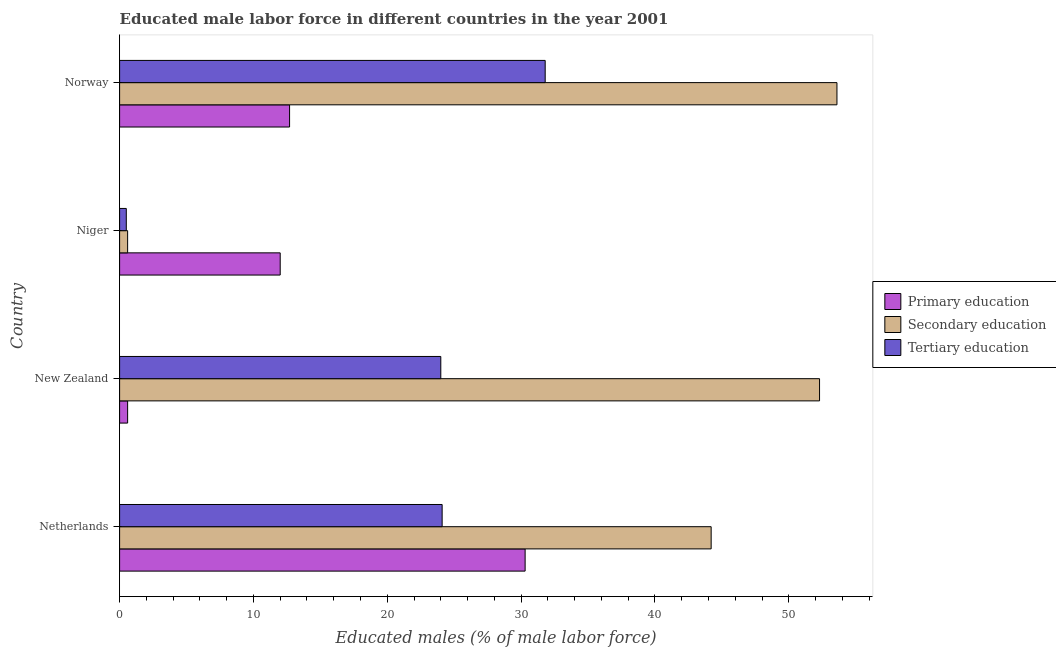How many bars are there on the 3rd tick from the top?
Ensure brevity in your answer.  3. How many bars are there on the 3rd tick from the bottom?
Provide a succinct answer. 3. What is the label of the 4th group of bars from the top?
Your answer should be very brief. Netherlands. What is the percentage of male labor force who received secondary education in Niger?
Give a very brief answer. 0.6. Across all countries, what is the maximum percentage of male labor force who received tertiary education?
Keep it short and to the point. 31.8. Across all countries, what is the minimum percentage of male labor force who received primary education?
Make the answer very short. 0.6. In which country was the percentage of male labor force who received primary education maximum?
Keep it short and to the point. Netherlands. In which country was the percentage of male labor force who received secondary education minimum?
Offer a terse response. Niger. What is the total percentage of male labor force who received primary education in the graph?
Offer a terse response. 55.6. What is the difference between the percentage of male labor force who received tertiary education in Netherlands and that in Niger?
Your answer should be very brief. 23.6. What is the difference between the percentage of male labor force who received primary education in Norway and the percentage of male labor force who received secondary education in Niger?
Your response must be concise. 12.1. What is the average percentage of male labor force who received secondary education per country?
Offer a very short reply. 37.67. What is the difference between the percentage of male labor force who received primary education and percentage of male labor force who received tertiary education in New Zealand?
Provide a succinct answer. -23.4. What is the ratio of the percentage of male labor force who received tertiary education in Netherlands to that in Niger?
Make the answer very short. 48.2. What is the difference between the highest and the second highest percentage of male labor force who received secondary education?
Provide a short and direct response. 1.3. What is the difference between the highest and the lowest percentage of male labor force who received primary education?
Your answer should be compact. 29.7. Is the sum of the percentage of male labor force who received secondary education in New Zealand and Norway greater than the maximum percentage of male labor force who received primary education across all countries?
Make the answer very short. Yes. What does the 1st bar from the top in Netherlands represents?
Provide a short and direct response. Tertiary education. What does the 2nd bar from the bottom in Norway represents?
Provide a short and direct response. Secondary education. Is it the case that in every country, the sum of the percentage of male labor force who received primary education and percentage of male labor force who received secondary education is greater than the percentage of male labor force who received tertiary education?
Provide a short and direct response. Yes. How many bars are there?
Keep it short and to the point. 12. Are all the bars in the graph horizontal?
Give a very brief answer. Yes. Are the values on the major ticks of X-axis written in scientific E-notation?
Offer a very short reply. No. Where does the legend appear in the graph?
Make the answer very short. Center right. How many legend labels are there?
Offer a terse response. 3. What is the title of the graph?
Your answer should be compact. Educated male labor force in different countries in the year 2001. Does "Consumption Tax" appear as one of the legend labels in the graph?
Your answer should be compact. No. What is the label or title of the X-axis?
Offer a terse response. Educated males (% of male labor force). What is the label or title of the Y-axis?
Offer a terse response. Country. What is the Educated males (% of male labor force) of Primary education in Netherlands?
Provide a short and direct response. 30.3. What is the Educated males (% of male labor force) in Secondary education in Netherlands?
Your answer should be very brief. 44.2. What is the Educated males (% of male labor force) of Tertiary education in Netherlands?
Offer a very short reply. 24.1. What is the Educated males (% of male labor force) of Primary education in New Zealand?
Offer a very short reply. 0.6. What is the Educated males (% of male labor force) of Secondary education in New Zealand?
Provide a succinct answer. 52.3. What is the Educated males (% of male labor force) in Tertiary education in New Zealand?
Provide a succinct answer. 24. What is the Educated males (% of male labor force) of Secondary education in Niger?
Your answer should be compact. 0.6. What is the Educated males (% of male labor force) of Tertiary education in Niger?
Provide a succinct answer. 0.5. What is the Educated males (% of male labor force) of Primary education in Norway?
Keep it short and to the point. 12.7. What is the Educated males (% of male labor force) in Secondary education in Norway?
Provide a succinct answer. 53.6. What is the Educated males (% of male labor force) of Tertiary education in Norway?
Provide a succinct answer. 31.8. Across all countries, what is the maximum Educated males (% of male labor force) in Primary education?
Give a very brief answer. 30.3. Across all countries, what is the maximum Educated males (% of male labor force) in Secondary education?
Your answer should be very brief. 53.6. Across all countries, what is the maximum Educated males (% of male labor force) in Tertiary education?
Provide a short and direct response. 31.8. Across all countries, what is the minimum Educated males (% of male labor force) of Primary education?
Your response must be concise. 0.6. Across all countries, what is the minimum Educated males (% of male labor force) of Secondary education?
Keep it short and to the point. 0.6. Across all countries, what is the minimum Educated males (% of male labor force) of Tertiary education?
Offer a very short reply. 0.5. What is the total Educated males (% of male labor force) in Primary education in the graph?
Give a very brief answer. 55.6. What is the total Educated males (% of male labor force) of Secondary education in the graph?
Provide a short and direct response. 150.7. What is the total Educated males (% of male labor force) of Tertiary education in the graph?
Your answer should be compact. 80.4. What is the difference between the Educated males (% of male labor force) of Primary education in Netherlands and that in New Zealand?
Ensure brevity in your answer.  29.7. What is the difference between the Educated males (% of male labor force) of Tertiary education in Netherlands and that in New Zealand?
Your answer should be very brief. 0.1. What is the difference between the Educated males (% of male labor force) of Secondary education in Netherlands and that in Niger?
Give a very brief answer. 43.6. What is the difference between the Educated males (% of male labor force) in Tertiary education in Netherlands and that in Niger?
Give a very brief answer. 23.6. What is the difference between the Educated males (% of male labor force) in Primary education in Netherlands and that in Norway?
Provide a succinct answer. 17.6. What is the difference between the Educated males (% of male labor force) in Tertiary education in Netherlands and that in Norway?
Offer a very short reply. -7.7. What is the difference between the Educated males (% of male labor force) of Secondary education in New Zealand and that in Niger?
Make the answer very short. 51.7. What is the difference between the Educated males (% of male labor force) of Tertiary education in New Zealand and that in Niger?
Your response must be concise. 23.5. What is the difference between the Educated males (% of male labor force) of Secondary education in New Zealand and that in Norway?
Your response must be concise. -1.3. What is the difference between the Educated males (% of male labor force) of Secondary education in Niger and that in Norway?
Give a very brief answer. -53. What is the difference between the Educated males (% of male labor force) in Tertiary education in Niger and that in Norway?
Provide a short and direct response. -31.3. What is the difference between the Educated males (% of male labor force) in Secondary education in Netherlands and the Educated males (% of male labor force) in Tertiary education in New Zealand?
Offer a very short reply. 20.2. What is the difference between the Educated males (% of male labor force) in Primary education in Netherlands and the Educated males (% of male labor force) in Secondary education in Niger?
Keep it short and to the point. 29.7. What is the difference between the Educated males (% of male labor force) in Primary education in Netherlands and the Educated males (% of male labor force) in Tertiary education in Niger?
Ensure brevity in your answer.  29.8. What is the difference between the Educated males (% of male labor force) in Secondary education in Netherlands and the Educated males (% of male labor force) in Tertiary education in Niger?
Offer a terse response. 43.7. What is the difference between the Educated males (% of male labor force) of Primary education in Netherlands and the Educated males (% of male labor force) of Secondary education in Norway?
Provide a short and direct response. -23.3. What is the difference between the Educated males (% of male labor force) of Secondary education in Netherlands and the Educated males (% of male labor force) of Tertiary education in Norway?
Offer a terse response. 12.4. What is the difference between the Educated males (% of male labor force) of Primary education in New Zealand and the Educated males (% of male labor force) of Secondary education in Niger?
Your response must be concise. 0. What is the difference between the Educated males (% of male labor force) in Secondary education in New Zealand and the Educated males (% of male labor force) in Tertiary education in Niger?
Keep it short and to the point. 51.8. What is the difference between the Educated males (% of male labor force) in Primary education in New Zealand and the Educated males (% of male labor force) in Secondary education in Norway?
Provide a short and direct response. -53. What is the difference between the Educated males (% of male labor force) in Primary education in New Zealand and the Educated males (% of male labor force) in Tertiary education in Norway?
Your response must be concise. -31.2. What is the difference between the Educated males (% of male labor force) in Primary education in Niger and the Educated males (% of male labor force) in Secondary education in Norway?
Your answer should be very brief. -41.6. What is the difference between the Educated males (% of male labor force) of Primary education in Niger and the Educated males (% of male labor force) of Tertiary education in Norway?
Offer a terse response. -19.8. What is the difference between the Educated males (% of male labor force) of Secondary education in Niger and the Educated males (% of male labor force) of Tertiary education in Norway?
Ensure brevity in your answer.  -31.2. What is the average Educated males (% of male labor force) in Secondary education per country?
Your response must be concise. 37.67. What is the average Educated males (% of male labor force) of Tertiary education per country?
Offer a terse response. 20.1. What is the difference between the Educated males (% of male labor force) of Primary education and Educated males (% of male labor force) of Secondary education in Netherlands?
Your answer should be very brief. -13.9. What is the difference between the Educated males (% of male labor force) of Primary education and Educated males (% of male labor force) of Tertiary education in Netherlands?
Make the answer very short. 6.2. What is the difference between the Educated males (% of male labor force) of Secondary education and Educated males (% of male labor force) of Tertiary education in Netherlands?
Keep it short and to the point. 20.1. What is the difference between the Educated males (% of male labor force) of Primary education and Educated males (% of male labor force) of Secondary education in New Zealand?
Your response must be concise. -51.7. What is the difference between the Educated males (% of male labor force) of Primary education and Educated males (% of male labor force) of Tertiary education in New Zealand?
Offer a terse response. -23.4. What is the difference between the Educated males (% of male labor force) of Secondary education and Educated males (% of male labor force) of Tertiary education in New Zealand?
Offer a very short reply. 28.3. What is the difference between the Educated males (% of male labor force) in Secondary education and Educated males (% of male labor force) in Tertiary education in Niger?
Ensure brevity in your answer.  0.1. What is the difference between the Educated males (% of male labor force) of Primary education and Educated males (% of male labor force) of Secondary education in Norway?
Make the answer very short. -40.9. What is the difference between the Educated males (% of male labor force) in Primary education and Educated males (% of male labor force) in Tertiary education in Norway?
Offer a terse response. -19.1. What is the difference between the Educated males (% of male labor force) of Secondary education and Educated males (% of male labor force) of Tertiary education in Norway?
Keep it short and to the point. 21.8. What is the ratio of the Educated males (% of male labor force) in Primary education in Netherlands to that in New Zealand?
Ensure brevity in your answer.  50.5. What is the ratio of the Educated males (% of male labor force) in Secondary education in Netherlands to that in New Zealand?
Ensure brevity in your answer.  0.85. What is the ratio of the Educated males (% of male labor force) in Tertiary education in Netherlands to that in New Zealand?
Offer a terse response. 1. What is the ratio of the Educated males (% of male labor force) in Primary education in Netherlands to that in Niger?
Your answer should be very brief. 2.52. What is the ratio of the Educated males (% of male labor force) in Secondary education in Netherlands to that in Niger?
Make the answer very short. 73.67. What is the ratio of the Educated males (% of male labor force) of Tertiary education in Netherlands to that in Niger?
Make the answer very short. 48.2. What is the ratio of the Educated males (% of male labor force) of Primary education in Netherlands to that in Norway?
Make the answer very short. 2.39. What is the ratio of the Educated males (% of male labor force) of Secondary education in Netherlands to that in Norway?
Provide a succinct answer. 0.82. What is the ratio of the Educated males (% of male labor force) of Tertiary education in Netherlands to that in Norway?
Your response must be concise. 0.76. What is the ratio of the Educated males (% of male labor force) of Secondary education in New Zealand to that in Niger?
Offer a very short reply. 87.17. What is the ratio of the Educated males (% of male labor force) in Primary education in New Zealand to that in Norway?
Offer a very short reply. 0.05. What is the ratio of the Educated males (% of male labor force) in Secondary education in New Zealand to that in Norway?
Your answer should be very brief. 0.98. What is the ratio of the Educated males (% of male labor force) of Tertiary education in New Zealand to that in Norway?
Make the answer very short. 0.75. What is the ratio of the Educated males (% of male labor force) of Primary education in Niger to that in Norway?
Your response must be concise. 0.94. What is the ratio of the Educated males (% of male labor force) of Secondary education in Niger to that in Norway?
Ensure brevity in your answer.  0.01. What is the ratio of the Educated males (% of male labor force) of Tertiary education in Niger to that in Norway?
Keep it short and to the point. 0.02. What is the difference between the highest and the second highest Educated males (% of male labor force) of Primary education?
Ensure brevity in your answer.  17.6. What is the difference between the highest and the second highest Educated males (% of male labor force) of Tertiary education?
Provide a short and direct response. 7.7. What is the difference between the highest and the lowest Educated males (% of male labor force) in Primary education?
Make the answer very short. 29.7. What is the difference between the highest and the lowest Educated males (% of male labor force) of Tertiary education?
Give a very brief answer. 31.3. 